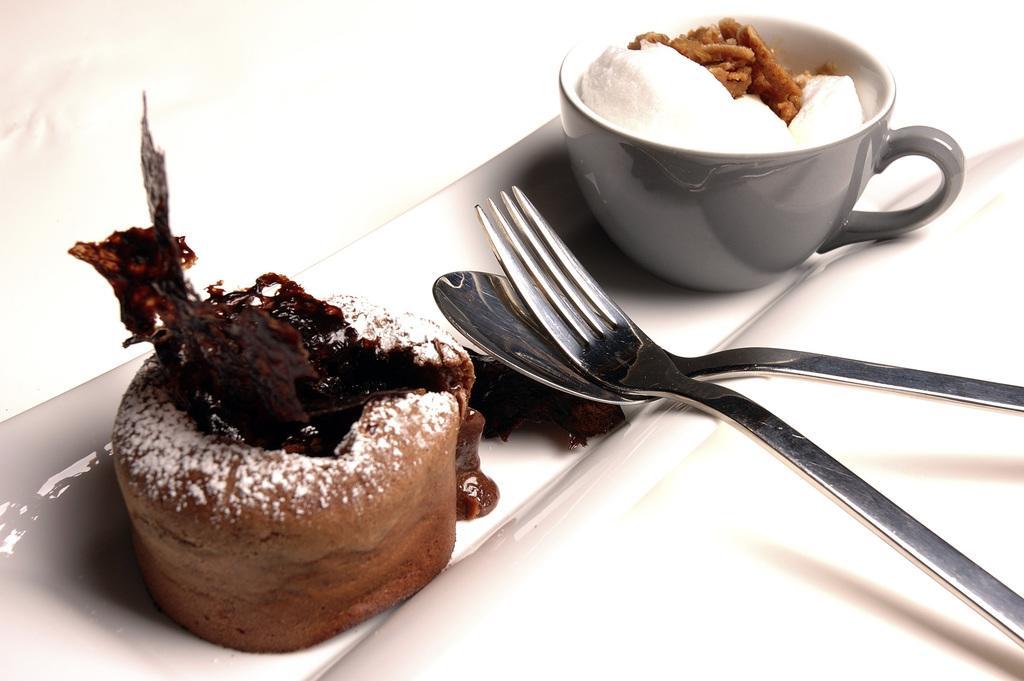In one or two sentences, can you explain what this image depicts? In this picture I can observe a cake and a cup in a tray. There are two spoons in the tray. 